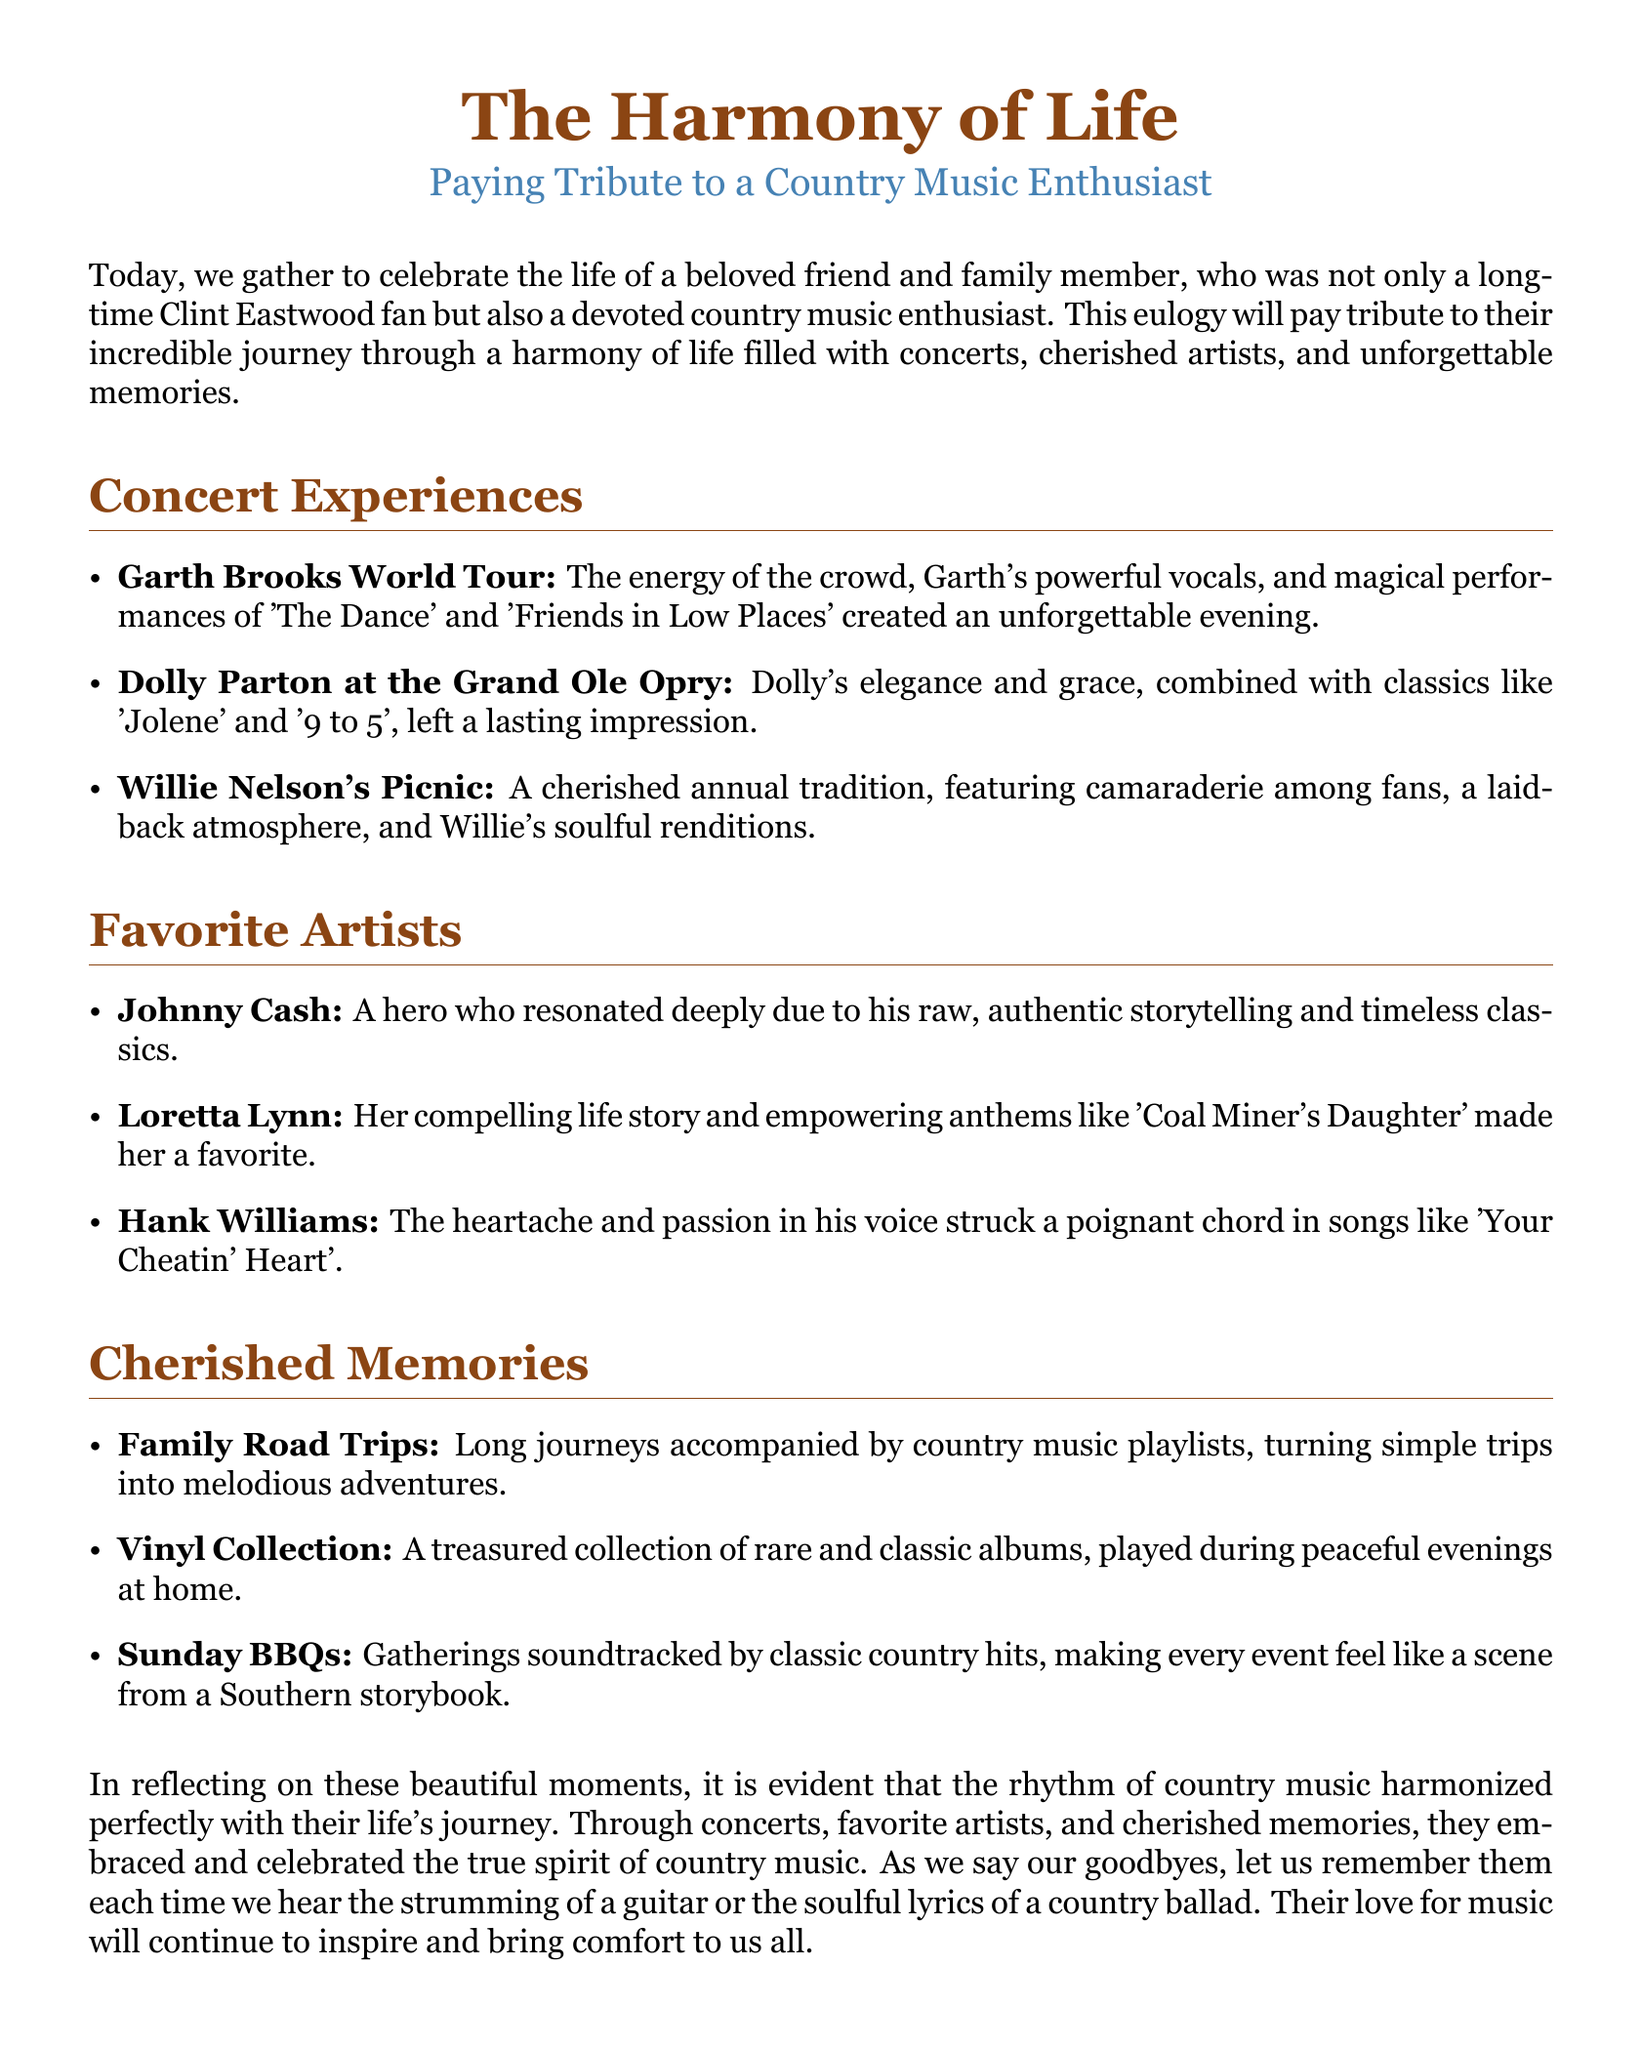what was the title of the eulogy? The title is explicitly stated at the beginning of the document.
Answer: The Harmony of Life who was a favorite country music artist mentioned? Several favorite artists are listed, specifically named in the document.
Answer: Johnny Cash which concert featured Dolly Parton? The document provides specific concerts attended by the individual.
Answer: Grand Ole Opry what song did Garth Brooks perform that is mentioned? The document lists specific songs performed during a concert.
Answer: The Dance what type of events were soundtracked by classic country hits? The document describes specific gatherings and their associated music.
Answer: Sunday BBQs how many favorite artists are listed in the document? The body of the eulogy states how many favorite artists are highlighted.
Answer: Three what song by Hank Williams is referred to in the eulogy? The document mentions a notable song that captures Hank Williams' essence.
Answer: Your Cheatin' Heart which annual tradition is mentioned in relation to Willie Nelson? The eulogy describes a specific event associated with Willie Nelson.
Answer: Picnic what type of collection is mentioned as treasured? The document lists items that hold personal value to the individual.
Answer: Vinyl Collection 